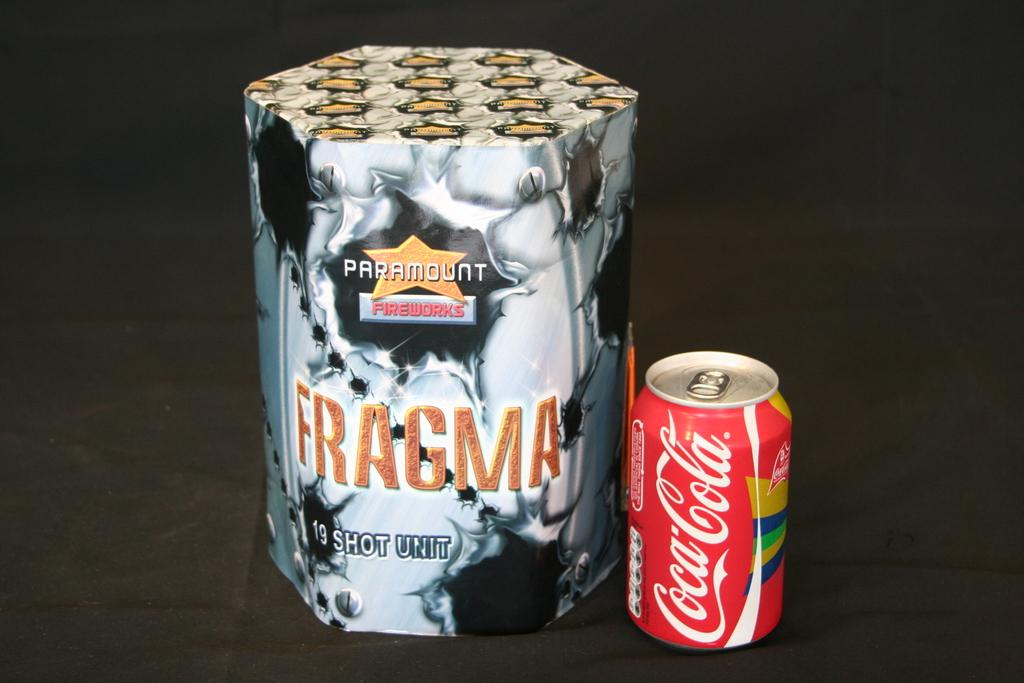<image>
Relay a brief, clear account of the picture shown. Paramount Fireworks that says Fragma 19 Shot Unit and a Coca Cola Can. 